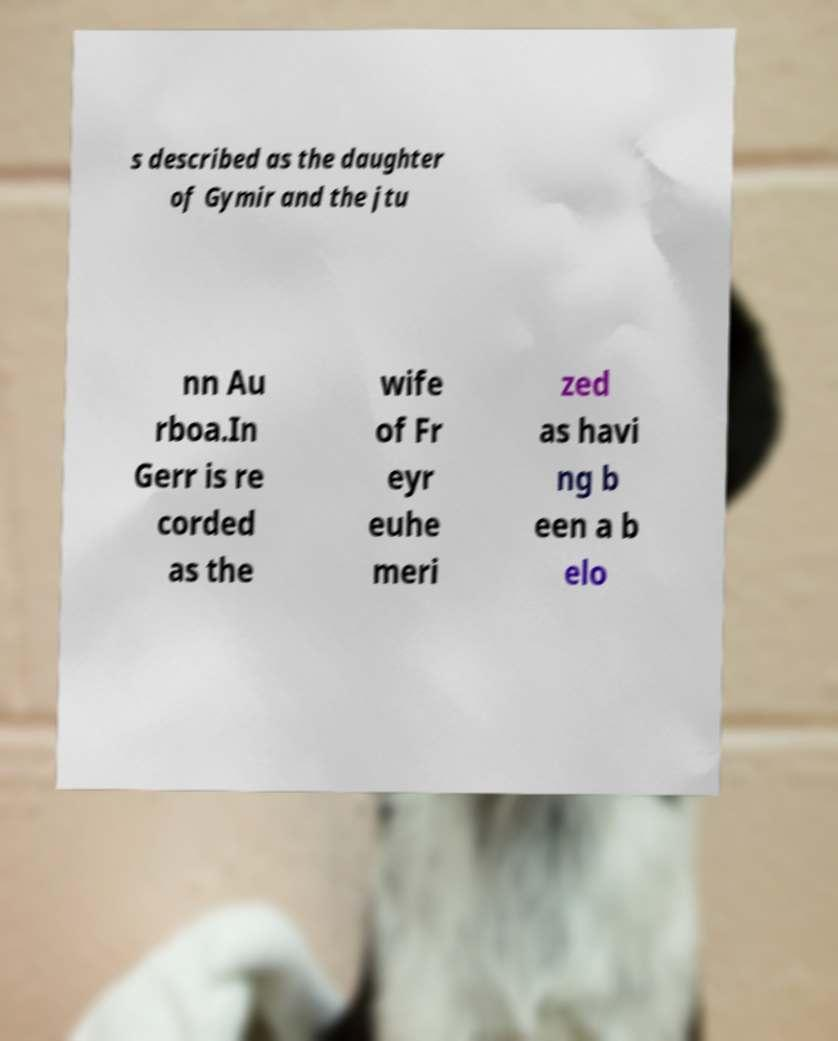Can you read and provide the text displayed in the image?This photo seems to have some interesting text. Can you extract and type it out for me? s described as the daughter of Gymir and the jtu nn Au rboa.In Gerr is re corded as the wife of Fr eyr euhe meri zed as havi ng b een a b elo 